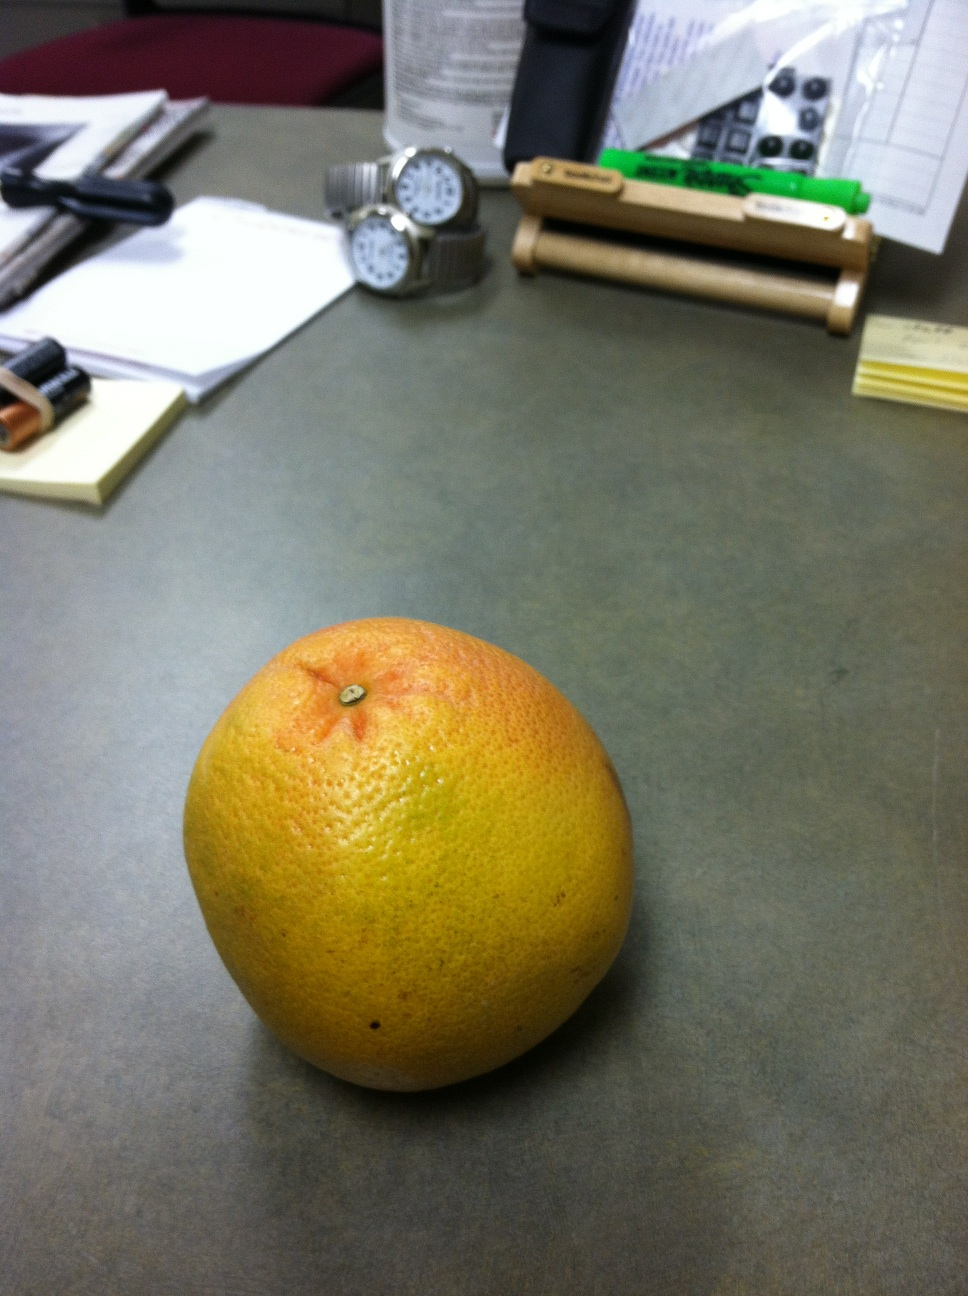Based on the image, construct a realistic scenario where someone uses the items on this desk for personal or work-related tasks. A researcher sits down at their desk early in the morning, ready to dive into a day of data analysis. They glance at the two watches to ensure they are synchronizing the time across their devices. With batteries in hand, they power up their wireless mouse and keyboard. The stack of papers includes the latest data sets and reports they need to review. Between sips of their morning coffee, they peel the grapefruit and enjoy it as a healthy snack. Mid-morning, they jot down notes from a phone call and organize their thoughts on sticky notes. By midday, they’ve moved through several tasks, feeling accomplished and ready for the afternoon's work. 